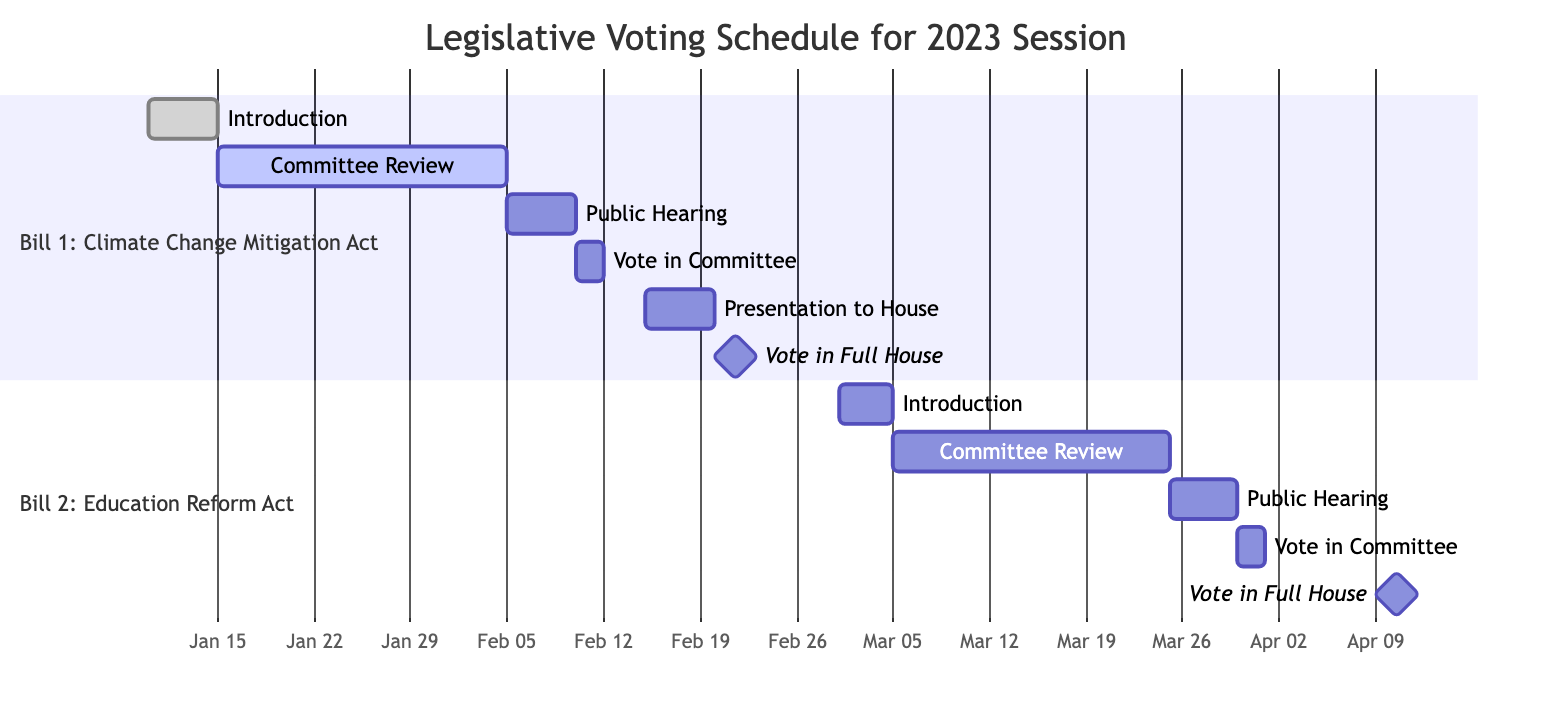what is the start date of the Public Hearing for Bill 1? The start date of the Public Hearing for Bill 1 is indicated in the diagram. It shows the task labeled "Public Hearing for Bill 1" starting on February 6, 2023.
Answer: February 6, 2023 how many tasks are listed under Bill 2: Education Reform Act? The diagram presents two sections, one for each bill. For Bill 2, there are a total of five tasks displayed: Introduction, Committee Review, Public Hearing, Vote in Committee, and Vote in Full House.
Answer: 5 what is the status of the Committee Review for Bill 1? The status is shown next to the task labeled "Committee Review for Bill 1." It is marked as "In Progress," which indicates that this task has not yet been completed.
Answer: In Progress what is the end date of the Committee Review for Bill 2? The end date can be found next to the task titled "Committee Review for Bill 2" in the diagram. It reveals that the end date is March 25, 2023.
Answer: March 25, 2023 when does the Vote in Full House for Bill 2 take place? The diagram specifies the Vote in Full House for Bill 2, showing the date it occurs. It is labeled as April 10, 2023, with a duration of one day, indicating the vote occurs on that specific day only.
Answer: April 10, 2023 what is the time period for the Committee Review of Bill 1? This can be determined by looking at the end and start dates of the task “Committee Review for Bill 1.” It starts on January 16, 2023, and ends on February 5, 2023. This indicates that the Committee Review spans a total of 20 days.
Answer: January 16, 2023 to February 5, 2023 which task follows the Public Hearing for Bill 1 in the schedule? The task directly following "Public Hearing for Bill 1" can be inferred from the diagram's layout and task dependencies. The next task is "Vote in Committee for Bill 1."
Answer: Vote in Committee for Bill 1 how many total unique voting events are shown in the schedule? By scanning through both sections of the diagram, each bill features a vote: Vote in Committee and Vote in Full House for both bills. Thus, there are four unique voting events in total.
Answer: 4 what is the status of the Public Hearing for Bill 2? The diagram notes the status next to the task "Public Hearing for Bill 2," which indicates it is "Upcoming," meaning this event has not yet occurred.
Answer: Upcoming 